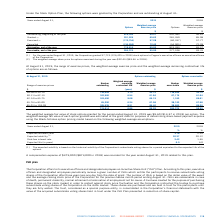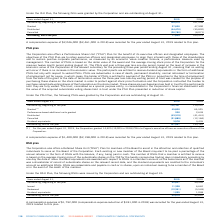According to Cogeco's financial document, How is  the number of ISUs determined? The number of ISUs is based on the dollar value of the award and the average closing stock price of the Corporation for the previous twelve month period ending August 31. The document states: "three years less one day from the date of grant. The number of ISUs is based on the dollar value of the award and the average closing stock price of t..." Also, What was the compensation expense in August 2019? According to the financial document, $2,046,000. The relevant text states: "A compensation expense of $2,046,000 ($2,461,000 in 2018) was recorded for the year ended August 31, 2019 related to this plan...." Also, What was the granted ISUs in 2019? According to the financial document, 37,600. The relevant text states: "Granted 37,600 47,900..." Also, can you calculate: What was the increase / (decrease) in the Outstanding, beginning of the year from 2018 to 2019? Based on the calculation: 105,475 - 101,538, the result is 3937. This is based on the information: "Outstanding, beginning of the year 105,475 101,538 Outstanding, beginning of the year 105,475 101,538..." The key data points involved are: 101,538, 105,475. Also, can you calculate: What was the average granted from 2018 to 2019? To answer this question, I need to perform calculations using the financial data. The calculation is: (37,600 + 47,900) / 2, which equals 42750. This is based on the information: "Granted 37,600 47,900 Granted 37,600 47,900..." The key data points involved are: 37,600, 47,900. Also, can you calculate: What was the average distributed from 2018 to 2019? To answer this question, I need to perform calculations using the financial data. The calculation is: -(44,470 + 35,892) / 2, which equals -40181. This is based on the information: "Distributed (44,470) (35,892) Distributed (44,470) (35,892)..." The key data points involved are: 35,892, 44,470. 